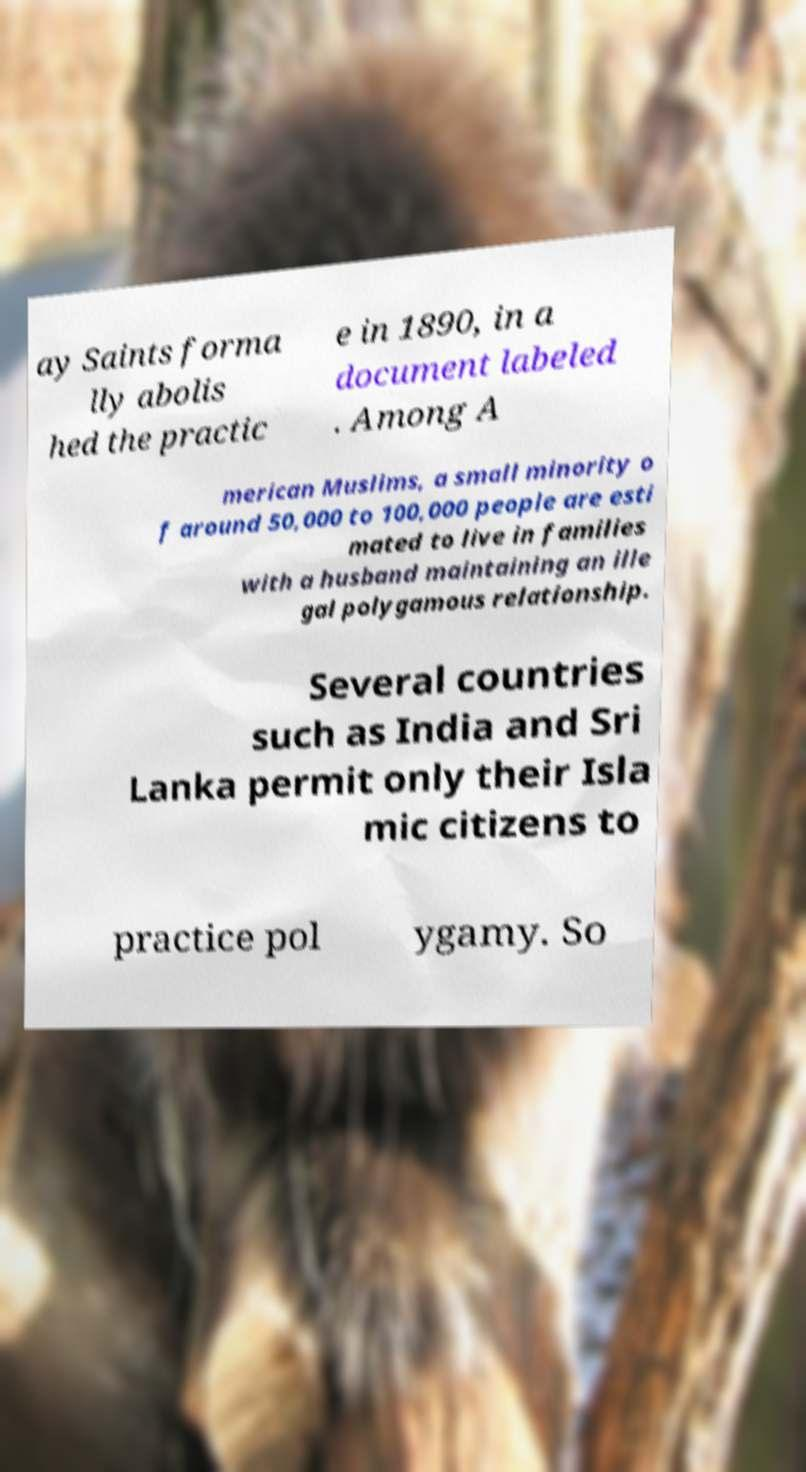Could you extract and type out the text from this image? ay Saints forma lly abolis hed the practic e in 1890, in a document labeled . Among A merican Muslims, a small minority o f around 50,000 to 100,000 people are esti mated to live in families with a husband maintaining an ille gal polygamous relationship. Several countries such as India and Sri Lanka permit only their Isla mic citizens to practice pol ygamy. So 